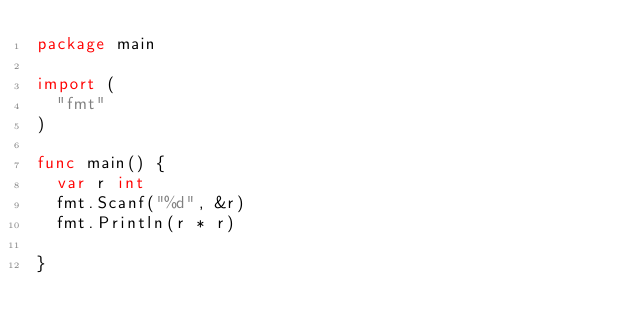Convert code to text. <code><loc_0><loc_0><loc_500><loc_500><_Go_>package main

import (
	"fmt"
)

func main() {
	var r int
	fmt.Scanf("%d", &r)
	fmt.Println(r * r)

}
</code> 